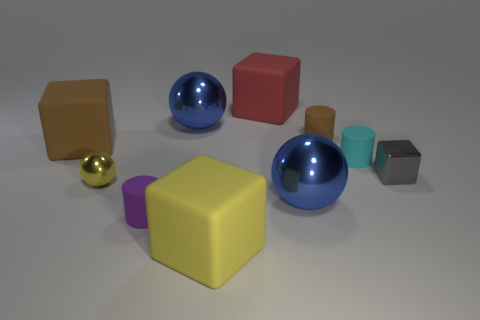Subtract all yellow spheres. How many spheres are left? 2 Subtract 1 cylinders. How many cylinders are left? 2 Subtract all gray blocks. How many blocks are left? 3 Subtract 0 blue blocks. How many objects are left? 10 Subtract all blocks. How many objects are left? 6 Subtract all cyan balls. Subtract all red cubes. How many balls are left? 3 Subtract all yellow cylinders. How many blue balls are left? 2 Subtract all large brown spheres. Subtract all tiny purple rubber cylinders. How many objects are left? 9 Add 4 small gray metal things. How many small gray metal things are left? 5 Add 8 tiny gray metallic cylinders. How many tiny gray metallic cylinders exist? 8 